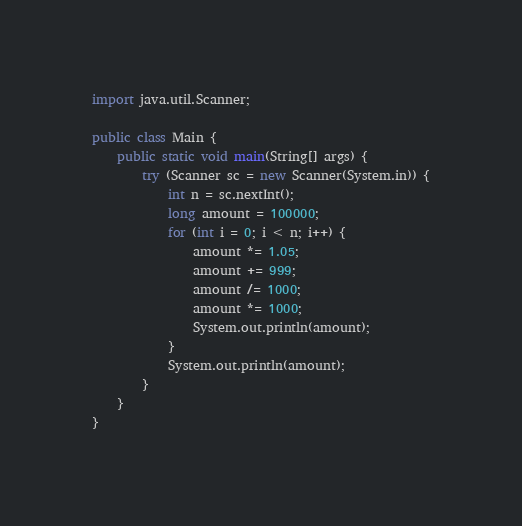<code> <loc_0><loc_0><loc_500><loc_500><_Java_>import java.util.Scanner;

public class Main {
	public static void main(String[] args) {
		try (Scanner sc = new Scanner(System.in)) {
			int n = sc.nextInt();
			long amount = 100000;
			for (int i = 0; i < n; i++) {
				amount *= 1.05;
				amount += 999;
				amount /= 1000;
				amount *= 1000;
				System.out.println(amount);
			}
			System.out.println(amount);
		}
	}
}</code> 